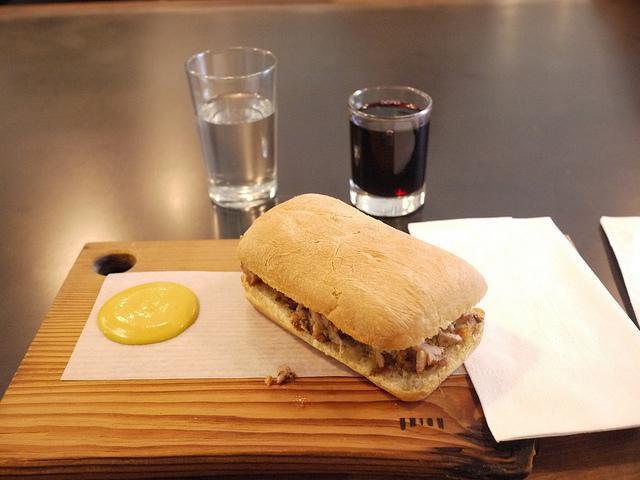How many glasses are there?
Give a very brief answer. 2. How many cups are there?
Give a very brief answer. 2. 